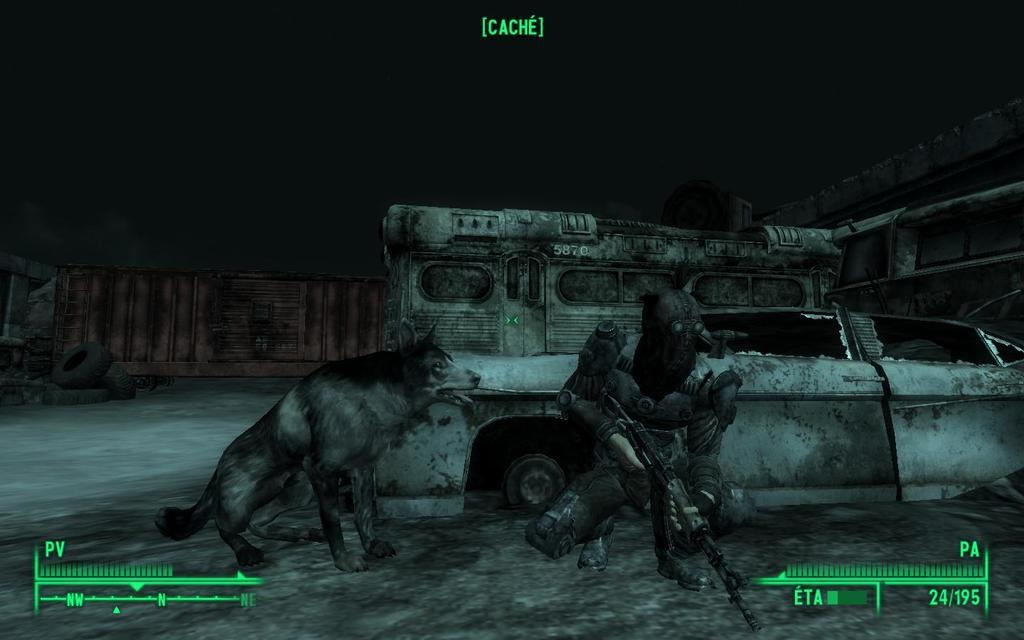What is the animated person holding in the image? The animated person is holding a gun in the image. What other living creature is present in the image? There is a dog beside the person in the image. What can be seen in the background of the image? There is a car, tires, and a wall in the background of the image. Where are the kittens hiding in the image? There are no kittens present in the image. What type of bean is being used as a prop in the image? There is no bean present in the image. 